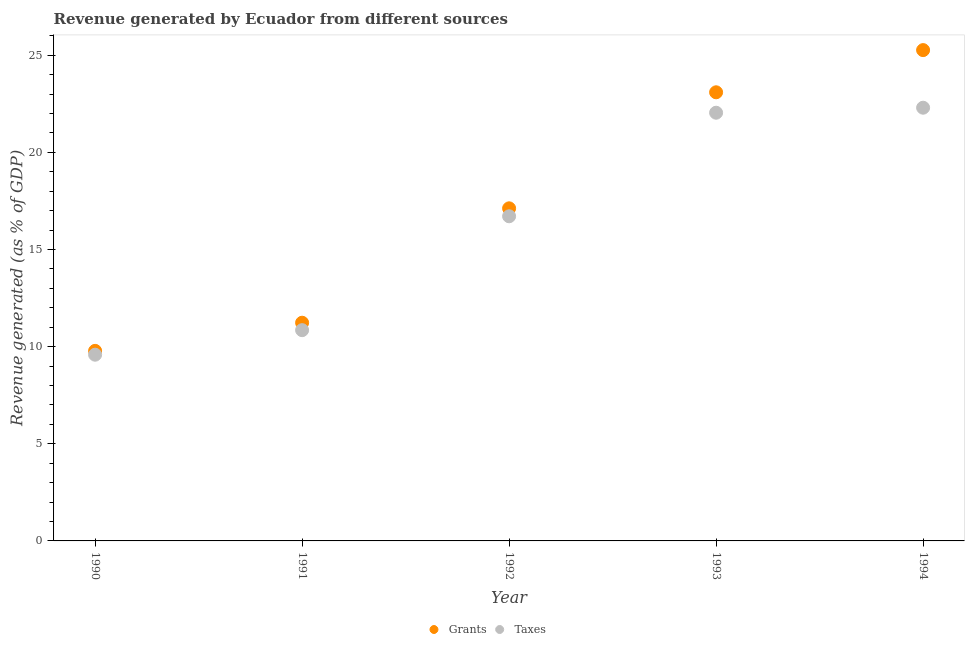What is the revenue generated by grants in 1990?
Provide a short and direct response. 9.78. Across all years, what is the maximum revenue generated by grants?
Provide a succinct answer. 25.26. Across all years, what is the minimum revenue generated by taxes?
Offer a very short reply. 9.59. In which year was the revenue generated by grants minimum?
Offer a very short reply. 1990. What is the total revenue generated by grants in the graph?
Your answer should be compact. 86.49. What is the difference between the revenue generated by taxes in 1992 and that in 1994?
Keep it short and to the point. -5.59. What is the difference between the revenue generated by taxes in 1994 and the revenue generated by grants in 1990?
Your answer should be compact. 12.52. What is the average revenue generated by grants per year?
Make the answer very short. 17.3. In the year 1991, what is the difference between the revenue generated by grants and revenue generated by taxes?
Provide a short and direct response. 0.38. What is the ratio of the revenue generated by taxes in 1992 to that in 1993?
Your answer should be compact. 0.76. Is the difference between the revenue generated by grants in 1990 and 1993 greater than the difference between the revenue generated by taxes in 1990 and 1993?
Offer a terse response. No. What is the difference between the highest and the second highest revenue generated by taxes?
Give a very brief answer. 0.26. What is the difference between the highest and the lowest revenue generated by grants?
Provide a short and direct response. 15.48. In how many years, is the revenue generated by taxes greater than the average revenue generated by taxes taken over all years?
Make the answer very short. 3. Is the sum of the revenue generated by grants in 1993 and 1994 greater than the maximum revenue generated by taxes across all years?
Your answer should be very brief. Yes. Is the revenue generated by grants strictly greater than the revenue generated by taxes over the years?
Offer a very short reply. Yes. How many years are there in the graph?
Ensure brevity in your answer.  5. Are the values on the major ticks of Y-axis written in scientific E-notation?
Keep it short and to the point. No. Does the graph contain any zero values?
Your answer should be very brief. No. Does the graph contain grids?
Make the answer very short. No. What is the title of the graph?
Make the answer very short. Revenue generated by Ecuador from different sources. Does "RDB concessional" appear as one of the legend labels in the graph?
Provide a short and direct response. No. What is the label or title of the Y-axis?
Your answer should be very brief. Revenue generated (as % of GDP). What is the Revenue generated (as % of GDP) of Grants in 1990?
Make the answer very short. 9.78. What is the Revenue generated (as % of GDP) in Taxes in 1990?
Your answer should be very brief. 9.59. What is the Revenue generated (as % of GDP) of Grants in 1991?
Give a very brief answer. 11.23. What is the Revenue generated (as % of GDP) of Taxes in 1991?
Give a very brief answer. 10.85. What is the Revenue generated (as % of GDP) of Grants in 1992?
Your answer should be very brief. 17.12. What is the Revenue generated (as % of GDP) of Taxes in 1992?
Keep it short and to the point. 16.71. What is the Revenue generated (as % of GDP) in Grants in 1993?
Provide a succinct answer. 23.09. What is the Revenue generated (as % of GDP) of Taxes in 1993?
Make the answer very short. 22.04. What is the Revenue generated (as % of GDP) of Grants in 1994?
Offer a terse response. 25.26. What is the Revenue generated (as % of GDP) in Taxes in 1994?
Keep it short and to the point. 22.3. Across all years, what is the maximum Revenue generated (as % of GDP) of Grants?
Your answer should be very brief. 25.26. Across all years, what is the maximum Revenue generated (as % of GDP) in Taxes?
Provide a short and direct response. 22.3. Across all years, what is the minimum Revenue generated (as % of GDP) in Grants?
Your answer should be very brief. 9.78. Across all years, what is the minimum Revenue generated (as % of GDP) of Taxes?
Offer a terse response. 9.59. What is the total Revenue generated (as % of GDP) in Grants in the graph?
Keep it short and to the point. 86.49. What is the total Revenue generated (as % of GDP) in Taxes in the graph?
Offer a terse response. 81.48. What is the difference between the Revenue generated (as % of GDP) of Grants in 1990 and that in 1991?
Your response must be concise. -1.45. What is the difference between the Revenue generated (as % of GDP) of Taxes in 1990 and that in 1991?
Your answer should be very brief. -1.26. What is the difference between the Revenue generated (as % of GDP) of Grants in 1990 and that in 1992?
Your answer should be very brief. -7.34. What is the difference between the Revenue generated (as % of GDP) in Taxes in 1990 and that in 1992?
Your answer should be compact. -7.12. What is the difference between the Revenue generated (as % of GDP) in Grants in 1990 and that in 1993?
Give a very brief answer. -13.31. What is the difference between the Revenue generated (as % of GDP) of Taxes in 1990 and that in 1993?
Make the answer very short. -12.45. What is the difference between the Revenue generated (as % of GDP) in Grants in 1990 and that in 1994?
Provide a short and direct response. -15.48. What is the difference between the Revenue generated (as % of GDP) of Taxes in 1990 and that in 1994?
Your answer should be very brief. -12.71. What is the difference between the Revenue generated (as % of GDP) in Grants in 1991 and that in 1992?
Offer a very short reply. -5.89. What is the difference between the Revenue generated (as % of GDP) of Taxes in 1991 and that in 1992?
Provide a short and direct response. -5.86. What is the difference between the Revenue generated (as % of GDP) in Grants in 1991 and that in 1993?
Provide a succinct answer. -11.86. What is the difference between the Revenue generated (as % of GDP) in Taxes in 1991 and that in 1993?
Your response must be concise. -11.19. What is the difference between the Revenue generated (as % of GDP) in Grants in 1991 and that in 1994?
Offer a very short reply. -14.03. What is the difference between the Revenue generated (as % of GDP) of Taxes in 1991 and that in 1994?
Make the answer very short. -11.45. What is the difference between the Revenue generated (as % of GDP) of Grants in 1992 and that in 1993?
Give a very brief answer. -5.97. What is the difference between the Revenue generated (as % of GDP) in Taxes in 1992 and that in 1993?
Keep it short and to the point. -5.33. What is the difference between the Revenue generated (as % of GDP) in Grants in 1992 and that in 1994?
Offer a terse response. -8.14. What is the difference between the Revenue generated (as % of GDP) in Taxes in 1992 and that in 1994?
Give a very brief answer. -5.59. What is the difference between the Revenue generated (as % of GDP) in Grants in 1993 and that in 1994?
Ensure brevity in your answer.  -2.17. What is the difference between the Revenue generated (as % of GDP) in Taxes in 1993 and that in 1994?
Your answer should be very brief. -0.26. What is the difference between the Revenue generated (as % of GDP) in Grants in 1990 and the Revenue generated (as % of GDP) in Taxes in 1991?
Your response must be concise. -1.07. What is the difference between the Revenue generated (as % of GDP) in Grants in 1990 and the Revenue generated (as % of GDP) in Taxes in 1992?
Make the answer very short. -6.93. What is the difference between the Revenue generated (as % of GDP) of Grants in 1990 and the Revenue generated (as % of GDP) of Taxes in 1993?
Your response must be concise. -12.26. What is the difference between the Revenue generated (as % of GDP) of Grants in 1990 and the Revenue generated (as % of GDP) of Taxes in 1994?
Offer a very short reply. -12.52. What is the difference between the Revenue generated (as % of GDP) of Grants in 1991 and the Revenue generated (as % of GDP) of Taxes in 1992?
Your answer should be compact. -5.48. What is the difference between the Revenue generated (as % of GDP) of Grants in 1991 and the Revenue generated (as % of GDP) of Taxes in 1993?
Ensure brevity in your answer.  -10.81. What is the difference between the Revenue generated (as % of GDP) in Grants in 1991 and the Revenue generated (as % of GDP) in Taxes in 1994?
Make the answer very short. -11.07. What is the difference between the Revenue generated (as % of GDP) of Grants in 1992 and the Revenue generated (as % of GDP) of Taxes in 1993?
Provide a succinct answer. -4.92. What is the difference between the Revenue generated (as % of GDP) in Grants in 1992 and the Revenue generated (as % of GDP) in Taxes in 1994?
Provide a succinct answer. -5.18. What is the difference between the Revenue generated (as % of GDP) in Grants in 1993 and the Revenue generated (as % of GDP) in Taxes in 1994?
Offer a very short reply. 0.79. What is the average Revenue generated (as % of GDP) in Grants per year?
Offer a very short reply. 17.3. What is the average Revenue generated (as % of GDP) of Taxes per year?
Your answer should be very brief. 16.3. In the year 1990, what is the difference between the Revenue generated (as % of GDP) of Grants and Revenue generated (as % of GDP) of Taxes?
Make the answer very short. 0.2. In the year 1991, what is the difference between the Revenue generated (as % of GDP) of Grants and Revenue generated (as % of GDP) of Taxes?
Provide a succinct answer. 0.38. In the year 1992, what is the difference between the Revenue generated (as % of GDP) of Grants and Revenue generated (as % of GDP) of Taxes?
Provide a short and direct response. 0.41. In the year 1993, what is the difference between the Revenue generated (as % of GDP) of Grants and Revenue generated (as % of GDP) of Taxes?
Ensure brevity in your answer.  1.05. In the year 1994, what is the difference between the Revenue generated (as % of GDP) in Grants and Revenue generated (as % of GDP) in Taxes?
Offer a very short reply. 2.97. What is the ratio of the Revenue generated (as % of GDP) in Grants in 1990 to that in 1991?
Provide a succinct answer. 0.87. What is the ratio of the Revenue generated (as % of GDP) of Taxes in 1990 to that in 1991?
Provide a short and direct response. 0.88. What is the ratio of the Revenue generated (as % of GDP) in Taxes in 1990 to that in 1992?
Make the answer very short. 0.57. What is the ratio of the Revenue generated (as % of GDP) in Grants in 1990 to that in 1993?
Keep it short and to the point. 0.42. What is the ratio of the Revenue generated (as % of GDP) in Taxes in 1990 to that in 1993?
Ensure brevity in your answer.  0.43. What is the ratio of the Revenue generated (as % of GDP) in Grants in 1990 to that in 1994?
Make the answer very short. 0.39. What is the ratio of the Revenue generated (as % of GDP) of Taxes in 1990 to that in 1994?
Provide a short and direct response. 0.43. What is the ratio of the Revenue generated (as % of GDP) of Grants in 1991 to that in 1992?
Give a very brief answer. 0.66. What is the ratio of the Revenue generated (as % of GDP) in Taxes in 1991 to that in 1992?
Make the answer very short. 0.65. What is the ratio of the Revenue generated (as % of GDP) of Grants in 1991 to that in 1993?
Keep it short and to the point. 0.49. What is the ratio of the Revenue generated (as % of GDP) of Taxes in 1991 to that in 1993?
Give a very brief answer. 0.49. What is the ratio of the Revenue generated (as % of GDP) of Grants in 1991 to that in 1994?
Make the answer very short. 0.44. What is the ratio of the Revenue generated (as % of GDP) in Taxes in 1991 to that in 1994?
Provide a short and direct response. 0.49. What is the ratio of the Revenue generated (as % of GDP) of Grants in 1992 to that in 1993?
Keep it short and to the point. 0.74. What is the ratio of the Revenue generated (as % of GDP) of Taxes in 1992 to that in 1993?
Your response must be concise. 0.76. What is the ratio of the Revenue generated (as % of GDP) of Grants in 1992 to that in 1994?
Offer a very short reply. 0.68. What is the ratio of the Revenue generated (as % of GDP) in Taxes in 1992 to that in 1994?
Your answer should be very brief. 0.75. What is the ratio of the Revenue generated (as % of GDP) of Grants in 1993 to that in 1994?
Ensure brevity in your answer.  0.91. What is the ratio of the Revenue generated (as % of GDP) in Taxes in 1993 to that in 1994?
Give a very brief answer. 0.99. What is the difference between the highest and the second highest Revenue generated (as % of GDP) in Grants?
Your answer should be very brief. 2.17. What is the difference between the highest and the second highest Revenue generated (as % of GDP) in Taxes?
Offer a very short reply. 0.26. What is the difference between the highest and the lowest Revenue generated (as % of GDP) of Grants?
Provide a short and direct response. 15.48. What is the difference between the highest and the lowest Revenue generated (as % of GDP) of Taxes?
Your answer should be compact. 12.71. 